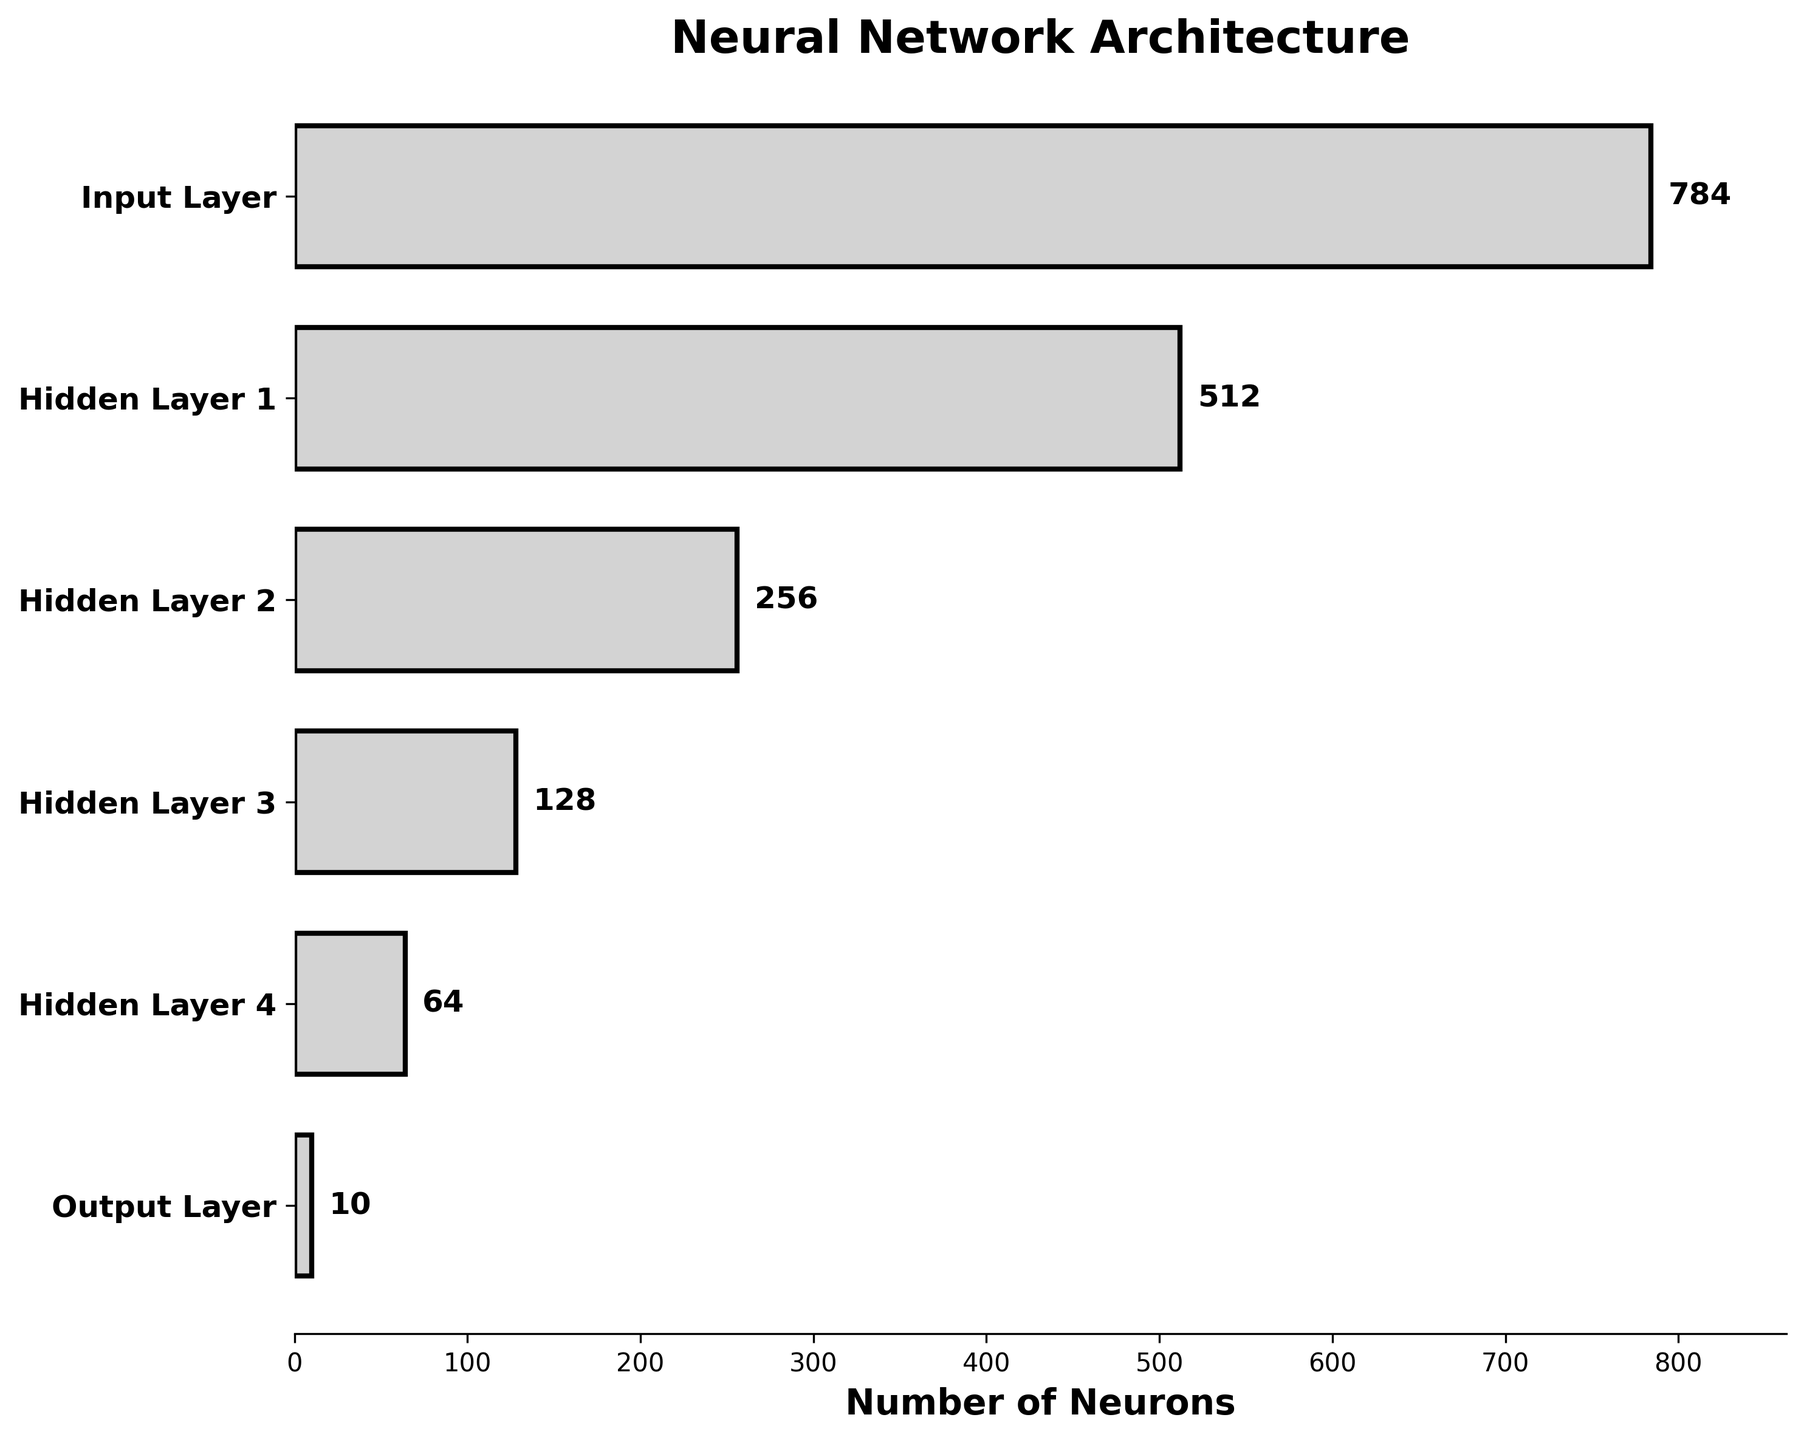What is the title of the figure? The title is displayed at the top of the figure, indicating what the visualization represents. Look above the chart for the text.
Answer: Neural Network Architecture How many neurons are in Hidden Layer 2? Locate Hidden Layer 2 on the y-axis, then look at the corresponding value on the bar representing the number of neurons.
Answer: 256 How many layers are depicted in the figure? Count the number of distinct layers listed on the y-axis.
Answer: 6 What is the decrease in the number of neurons from Hidden Layer 1 to Hidden Layer 3? Find the neuron counts for Hidden Layer 1 and Hidden Layer 3 (512 and 128) and subtract the latter from the former: 512 - 128.
Answer: 384 What is the total number of neurons across all layers? Add the neuron counts of all layers: 784 + 512 + 256 + 128 + 64 + 10.
Answer: 1754 What's the average number of neurons in the hidden layers? Sum the neuron counts of Hidden Layer 1, 2, 3, and 4 (512 + 256 + 128 + 64), then divide by 4.
Answer: 240 What can you infer about the structure of this neural network from the funnel shape? The decreasing width of the bars from the input layer to the output layer suggests that the neural network progressively reduces the number of neurons, indicating a tapering architecture commonly used for feature extraction and decision making.
Answer: Tapering architecture Compare the difference in neuron count between the Input Layer and the Output Layer. Subtract the neuron count of the Output Layer from the Input Layer: 784 - 10.
Answer: 774 